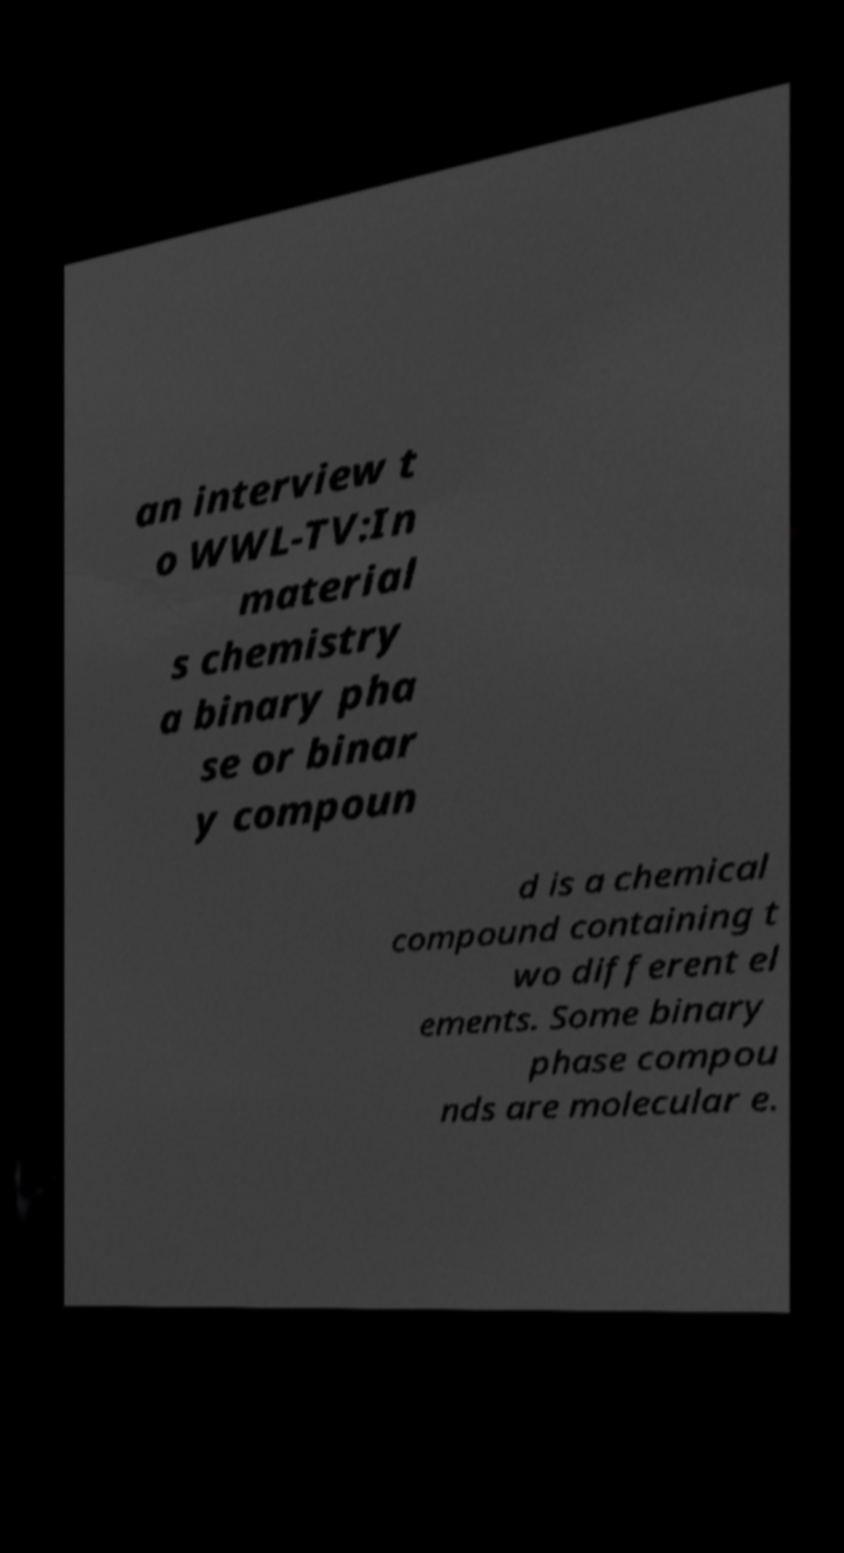For documentation purposes, I need the text within this image transcribed. Could you provide that? an interview t o WWL-TV:In material s chemistry a binary pha se or binar y compoun d is a chemical compound containing t wo different el ements. Some binary phase compou nds are molecular e. 